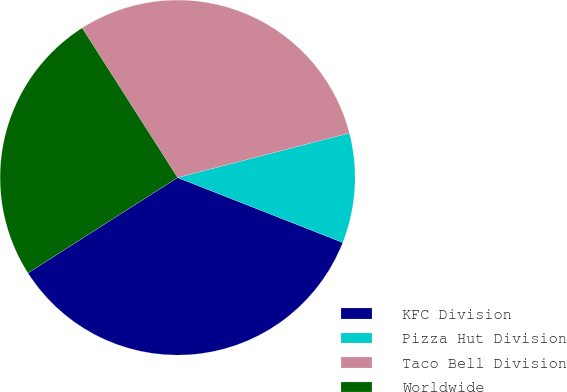Convert chart. <chart><loc_0><loc_0><loc_500><loc_500><pie_chart><fcel>KFC Division<fcel>Pizza Hut Division<fcel>Taco Bell Division<fcel>Worldwide<nl><fcel>35.0%<fcel>10.0%<fcel>30.0%<fcel>25.0%<nl></chart> 